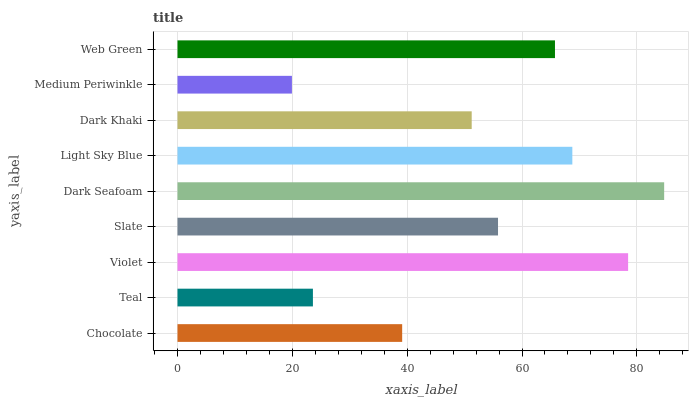Is Medium Periwinkle the minimum?
Answer yes or no. Yes. Is Dark Seafoam the maximum?
Answer yes or no. Yes. Is Teal the minimum?
Answer yes or no. No. Is Teal the maximum?
Answer yes or no. No. Is Chocolate greater than Teal?
Answer yes or no. Yes. Is Teal less than Chocolate?
Answer yes or no. Yes. Is Teal greater than Chocolate?
Answer yes or no. No. Is Chocolate less than Teal?
Answer yes or no. No. Is Slate the high median?
Answer yes or no. Yes. Is Slate the low median?
Answer yes or no. Yes. Is Web Green the high median?
Answer yes or no. No. Is Teal the low median?
Answer yes or no. No. 